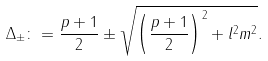<formula> <loc_0><loc_0><loc_500><loc_500>& \Delta _ { \pm } \colon = \frac { p + 1 } { 2 } \pm \sqrt { \left ( \frac { p + 1 } { 2 } \right ) ^ { 2 } + l ^ { 2 } m ^ { 2 } } .</formula> 